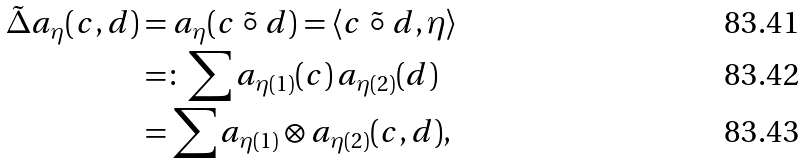<formula> <loc_0><loc_0><loc_500><loc_500>\tilde { \Delta } a _ { \eta } ( c , d ) & = a _ { \eta } ( c \ \tilde { \circ } \ d ) = \langle c \ \tilde { \circ } \ d , \eta \rangle \\ & = \colon \sum a _ { \eta ( 1 ) } ( c ) \, a _ { \eta ( 2 ) } ( d ) \\ & = \sum a _ { \eta ( 1 ) } \otimes a _ { \eta ( 2 ) } ( c , d ) ,</formula> 